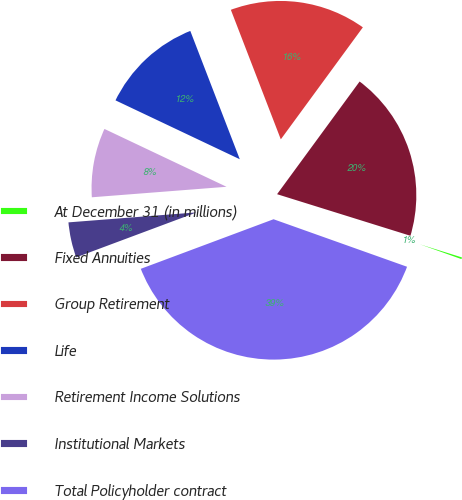<chart> <loc_0><loc_0><loc_500><loc_500><pie_chart><fcel>At December 31 (in millions)<fcel>Fixed Annuities<fcel>Group Retirement<fcel>Life<fcel>Retirement Income Solutions<fcel>Institutional Markets<fcel>Total Policyholder contract<nl><fcel>0.63%<fcel>19.75%<fcel>15.92%<fcel>12.1%<fcel>8.28%<fcel>4.45%<fcel>38.87%<nl></chart> 